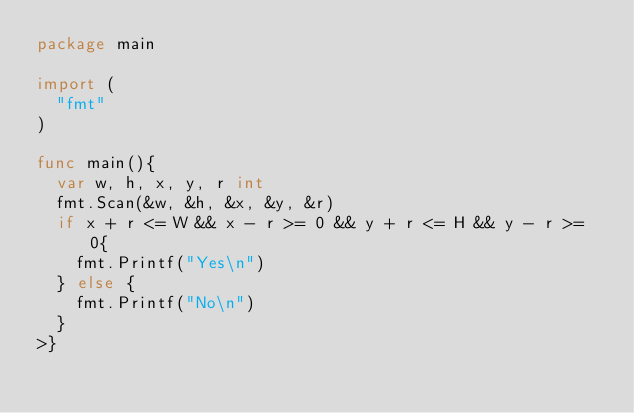<code> <loc_0><loc_0><loc_500><loc_500><_Go_>package main

import (
	"fmt"
)

func main(){
	var w, h, x, y, r int
	fmt.Scan(&w, &h, &x, &y, &r)
	if x + r <= W && x - r >= 0 && y + r <= H && y - r >= 0{
		fmt.Printf("Yes\n")
	} else {
		fmt.Printf("No\n")
	}
>}
</code> 